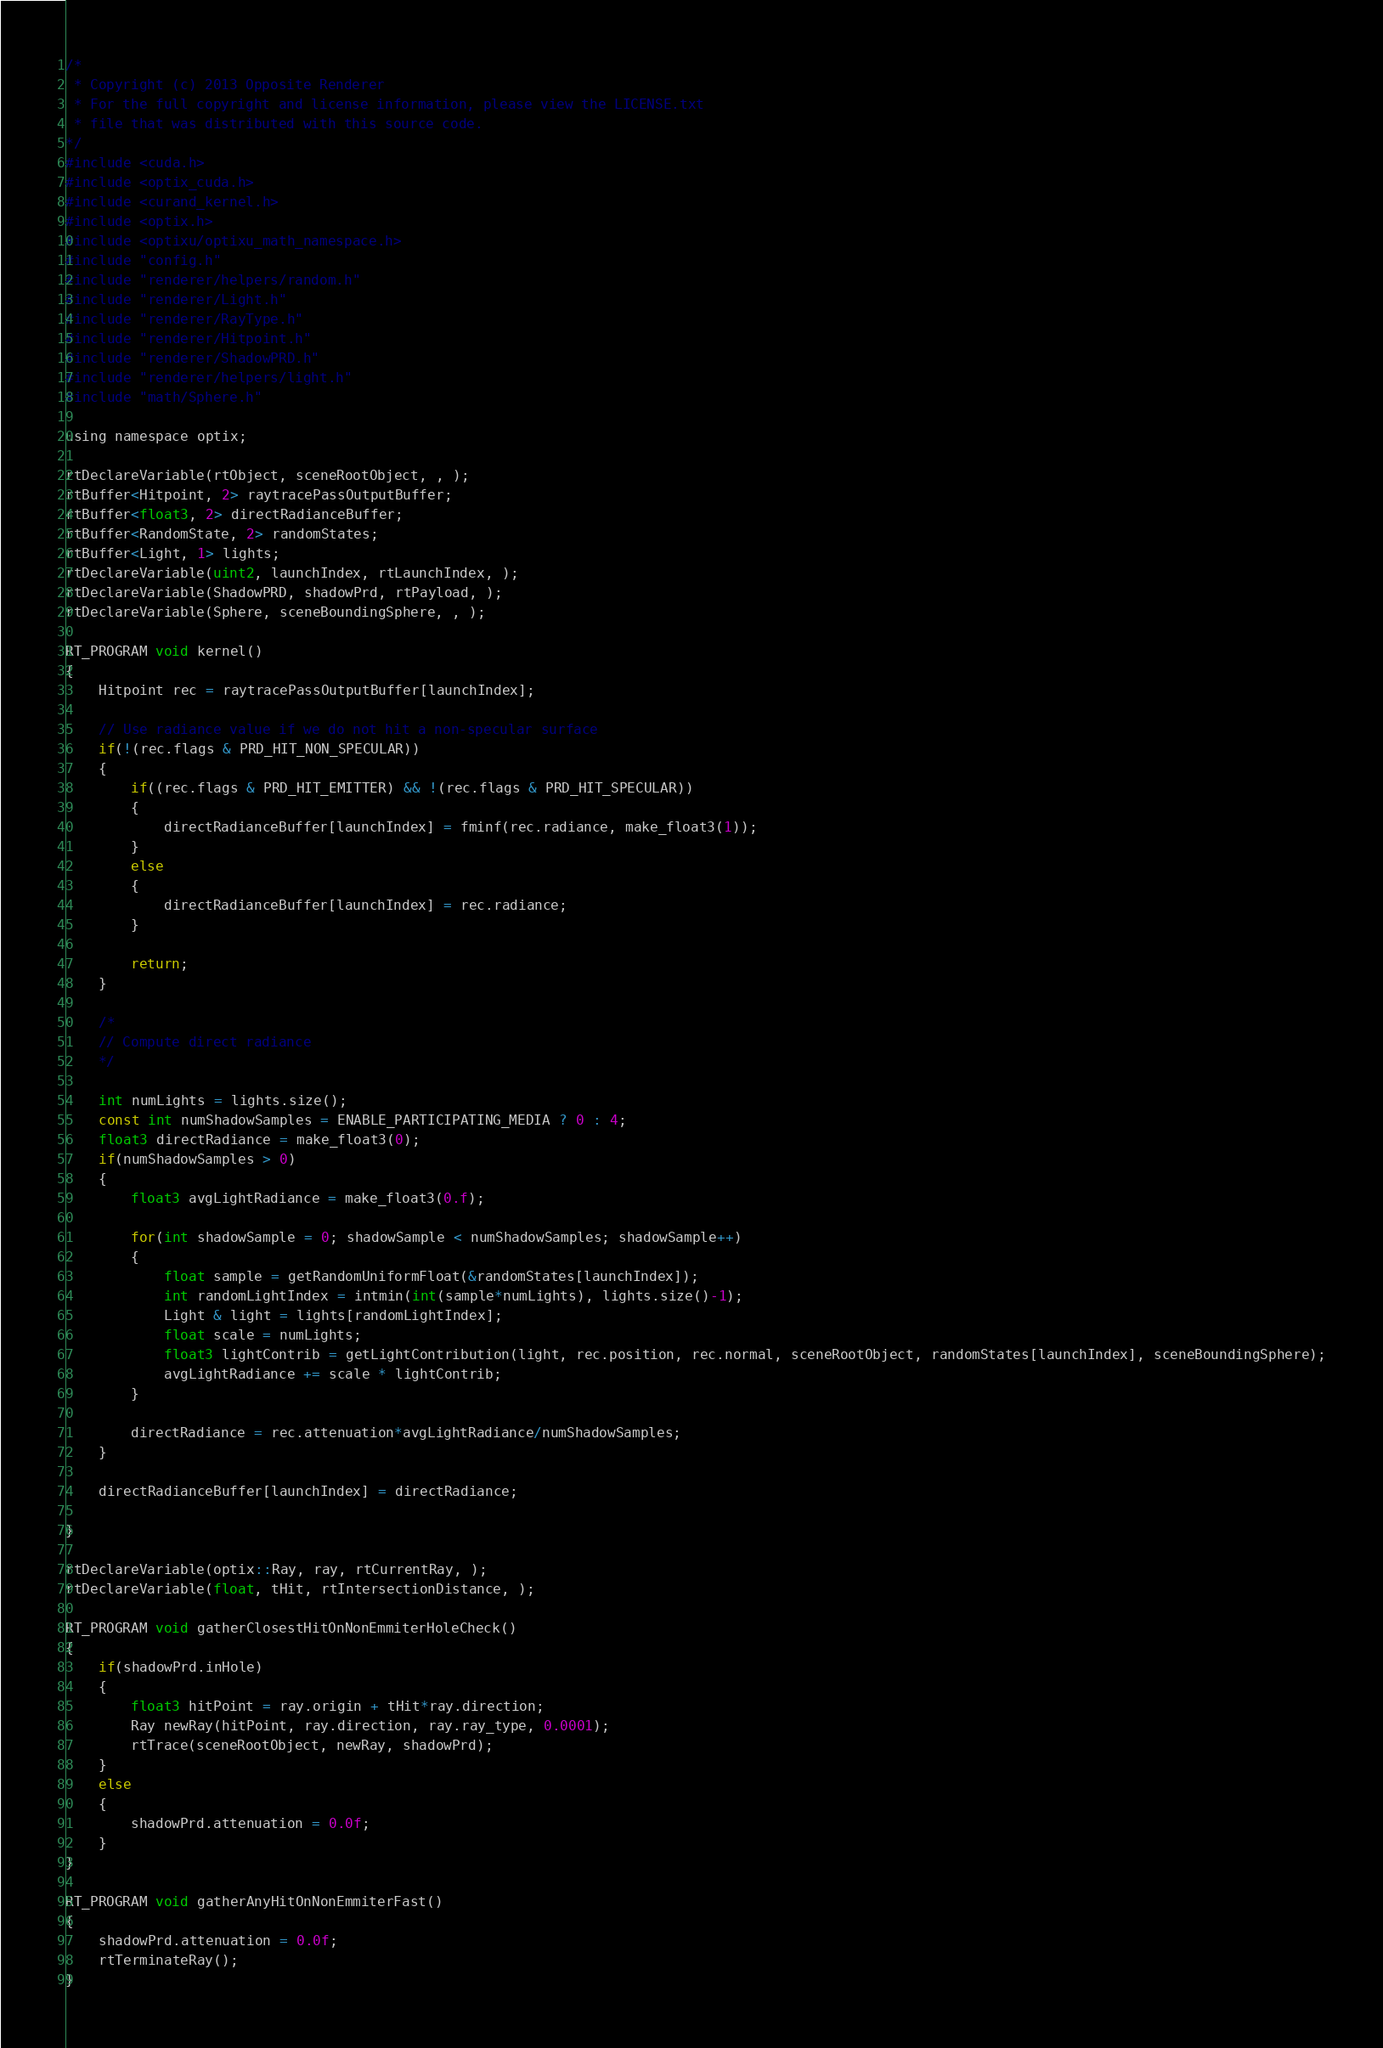Convert code to text. <code><loc_0><loc_0><loc_500><loc_500><_Cuda_>/* 
 * Copyright (c) 2013 Opposite Renderer
 * For the full copyright and license information, please view the LICENSE.txt
 * file that was distributed with this source code.
*/
#include <cuda.h>
#include <optix_cuda.h>
#include <curand_kernel.h>
#include <optix.h>
#include <optixu/optixu_math_namespace.h>
#include "config.h"
#include "renderer/helpers/random.h"
#include "renderer/Light.h"
#include "renderer/RayType.h"
#include "renderer/Hitpoint.h"
#include "renderer/ShadowPRD.h"
#include "renderer/helpers/light.h"
#include "math/Sphere.h"

using namespace optix;

rtDeclareVariable(rtObject, sceneRootObject, , );
rtBuffer<Hitpoint, 2> raytracePassOutputBuffer;
rtBuffer<float3, 2> directRadianceBuffer;
rtBuffer<RandomState, 2> randomStates;
rtBuffer<Light, 1> lights;
rtDeclareVariable(uint2, launchIndex, rtLaunchIndex, );
rtDeclareVariable(ShadowPRD, shadowPrd, rtPayload, );
rtDeclareVariable(Sphere, sceneBoundingSphere, , );

RT_PROGRAM void kernel()
{
    Hitpoint rec = raytracePassOutputBuffer[launchIndex];
    
    // Use radiance value if we do not hit a non-specular surface
    if(!(rec.flags & PRD_HIT_NON_SPECULAR))
    {
        if((rec.flags & PRD_HIT_EMITTER) && !(rec.flags & PRD_HIT_SPECULAR))
        {
            directRadianceBuffer[launchIndex] = fminf(rec.radiance, make_float3(1));
        }
        else
        {
            directRadianceBuffer[launchIndex] = rec.radiance;
        }

        return;
    }

    /*
    // Compute direct radiance
    */

    int numLights = lights.size();
    const int numShadowSamples = ENABLE_PARTICIPATING_MEDIA ? 0 : 4;
    float3 directRadiance = make_float3(0);
    if(numShadowSamples > 0)
    {
        float3 avgLightRadiance = make_float3(0.f);

        for(int shadowSample = 0; shadowSample < numShadowSamples; shadowSample++)
        {
            float sample = getRandomUniformFloat(&randomStates[launchIndex]);
            int randomLightIndex = intmin(int(sample*numLights), lights.size()-1);
            Light & light = lights[randomLightIndex];
            float scale = numLights;
			float3 lightContrib = getLightContribution(light, rec.position, rec.normal, sceneRootObject, randomStates[launchIndex], sceneBoundingSphere);
			avgLightRadiance += scale * lightContrib;
        }

        directRadiance = rec.attenuation*avgLightRadiance/numShadowSamples;
    }

    directRadianceBuffer[launchIndex] = directRadiance;
    
}

rtDeclareVariable(optix::Ray, ray, rtCurrentRay, );
rtDeclareVariable(float, tHit, rtIntersectionDistance, );

RT_PROGRAM void gatherClosestHitOnNonEmmiterHoleCheck()
{
	if(shadowPrd.inHole)
	{
		float3 hitPoint = ray.origin + tHit*ray.direction;
		Ray newRay(hitPoint, ray.direction, ray.ray_type, 0.0001);
		rtTrace(sceneRootObject, newRay, shadowPrd);
	}
	else
	{
		shadowPrd.attenuation = 0.0f;
	}
}

RT_PROGRAM void gatherAnyHitOnNonEmmiterFast()
{
	shadowPrd.attenuation = 0.0f;
	rtTerminateRay();
}</code> 